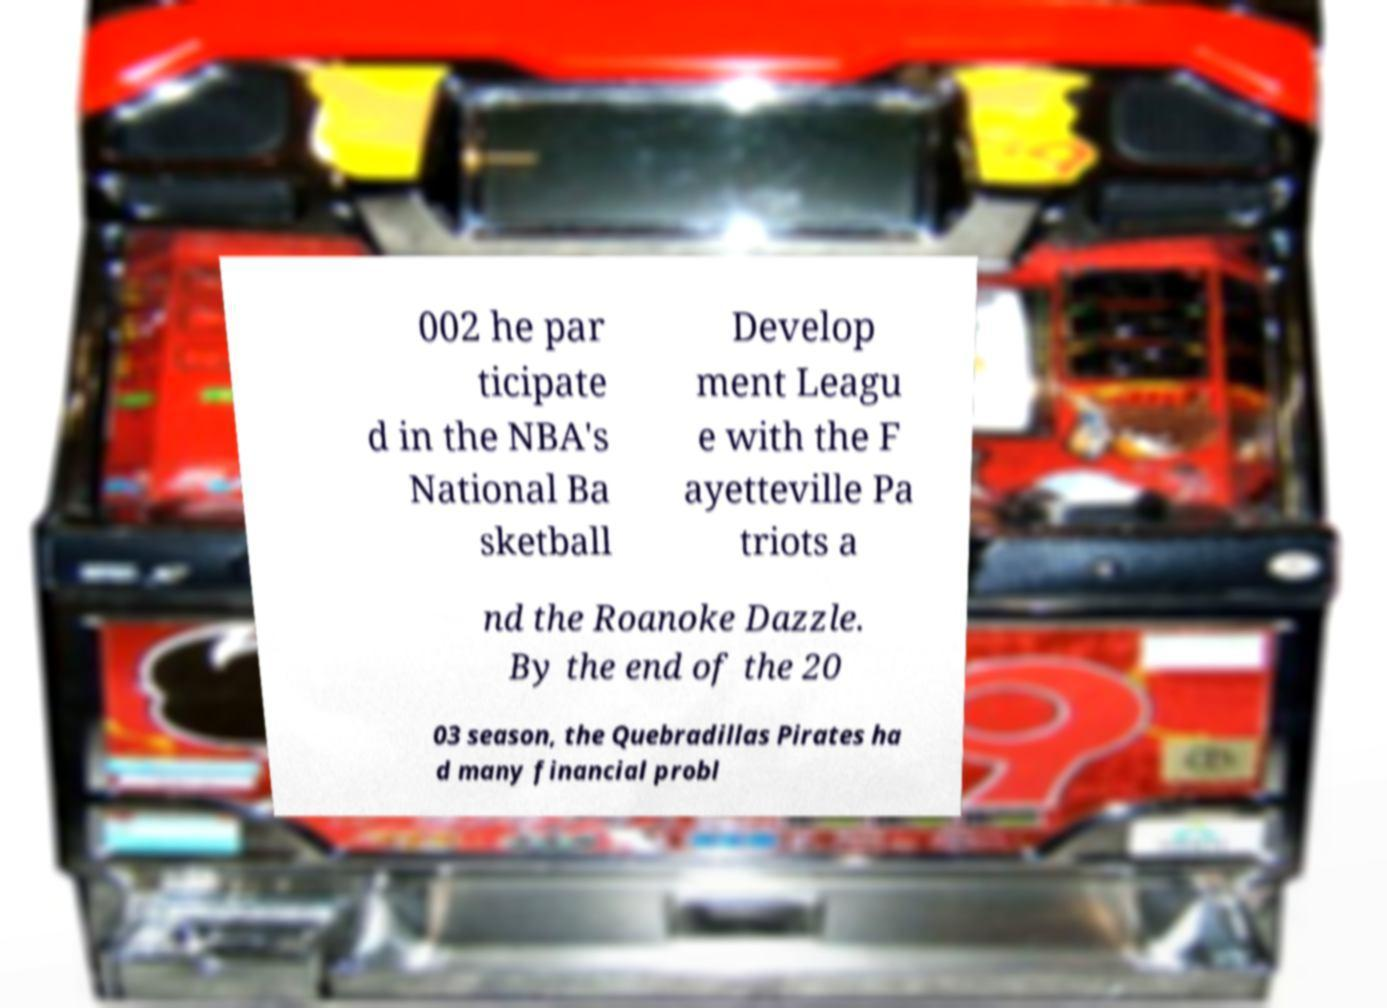What messages or text are displayed in this image? I need them in a readable, typed format. 002 he par ticipate d in the NBA's National Ba sketball Develop ment Leagu e with the F ayetteville Pa triots a nd the Roanoke Dazzle. By the end of the 20 03 season, the Quebradillas Pirates ha d many financial probl 